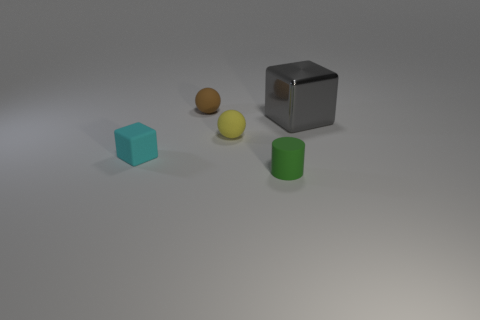Subtract all blue cubes. Subtract all cyan balls. How many cubes are left? 2 Add 5 small yellow rubber balls. How many objects exist? 10 Subtract all cylinders. How many objects are left? 4 Add 3 rubber spheres. How many rubber spheres exist? 5 Subtract 0 blue balls. How many objects are left? 5 Subtract all small cyan rubber cubes. Subtract all balls. How many objects are left? 2 Add 2 matte objects. How many matte objects are left? 6 